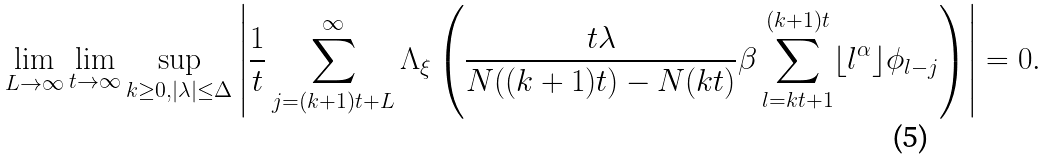Convert formula to latex. <formula><loc_0><loc_0><loc_500><loc_500>\lim _ { L \rightarrow \infty } \lim _ { t \rightarrow \infty } \sup _ { k \geq 0 , | \lambda | \leq \Delta } \left | \frac { 1 } { t } \sum _ { j = ( k + 1 ) t + L } ^ { \infty } \Lambda _ { \xi } \left ( \frac { t \lambda } { N ( ( k + 1 ) t ) - N ( k t ) } \beta \sum _ { l = k t + 1 } ^ { ( k + 1 ) t } \lfloor l ^ { \alpha } \rfloor \phi _ { l - j } \right ) \right | = 0 .</formula> 